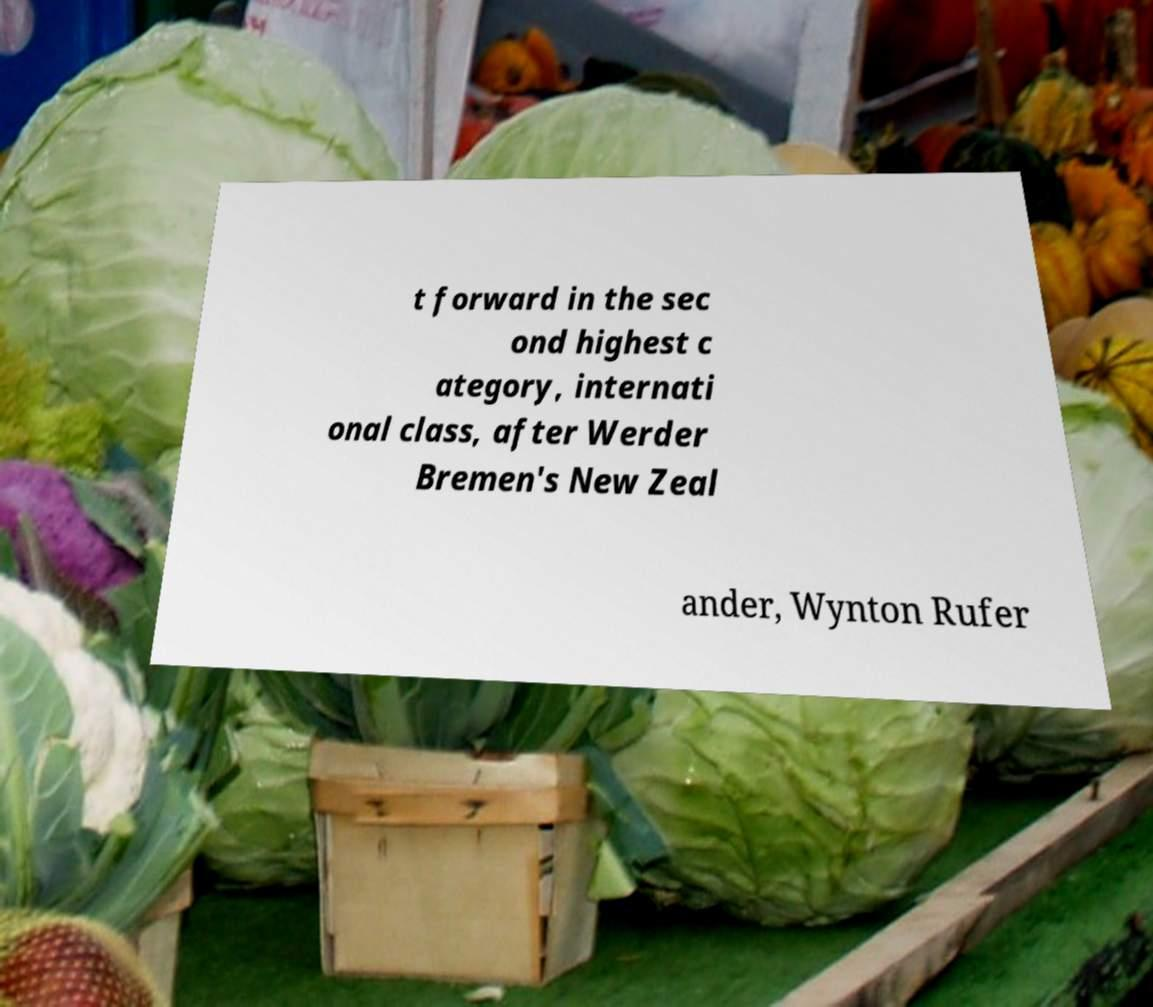Can you accurately transcribe the text from the provided image for me? t forward in the sec ond highest c ategory, internati onal class, after Werder Bremen's New Zeal ander, Wynton Rufer 